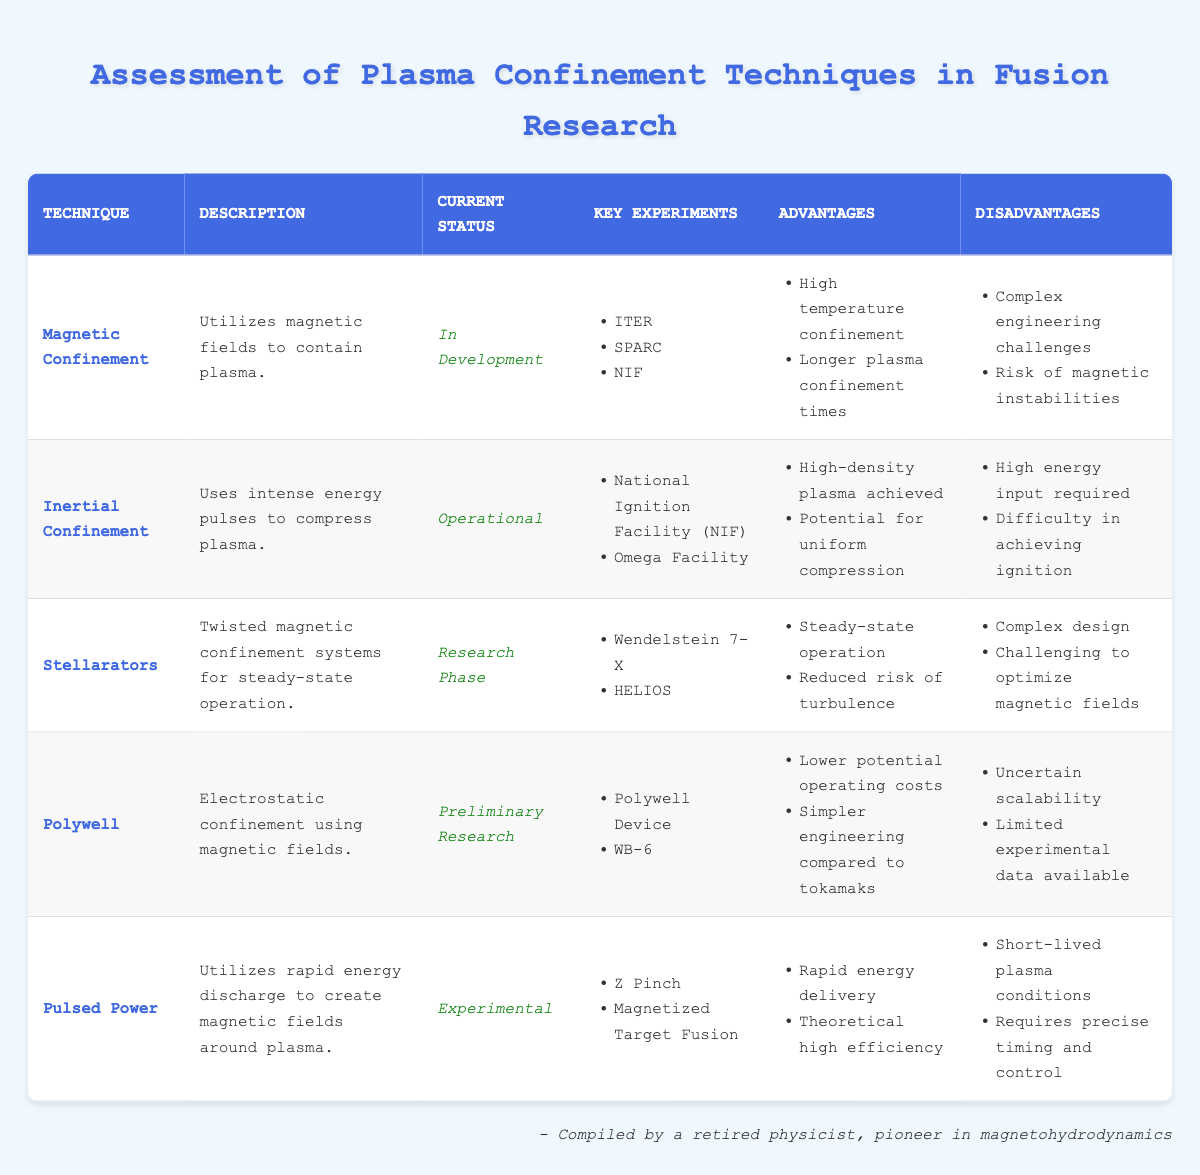What is the current status of Magnetic Confinement? The table explicitly states that the current status of Magnetic Confinement is "In Development".
Answer: In Development Which technique has the potential for uniform compression? The advantages listed for Inertial Confinement include "Potential for uniform compression".
Answer: Inertial Confinement How many key experiments are associated with Stellarators? The table indicates that there are two key experiments associated with Stellarators: Wendelstein 7-X and HELIOS.
Answer: 2 Is the Polywell technique currently operational? The current status of Polywell is noted as "Preliminary Research", which means it is not operational.
Answer: No Comparing the advantages, how many techniques have "high temperature confinement" listed? Only the Magnetic Confinement technique has "High temperature confinement" among its advantages.
Answer: 1 What are the disadvantages of Pulsed Power? The table lists two disadvantages for Pulsed Power: "Short-lived plasma conditions" and "Requires precise timing and control".
Answer: 2 Which plasma confinement technique is in the research phase and has reduced risk of turbulence? The technique is Stellarators, as highlighted in the table under its advantages.
Answer: Stellarators Which technique requires the highest energy input according to the disadvantages? The disadvantages of Inertial Confinement state that "High energy input required", indicating it requires the highest energy.
Answer: Inertial Confinement Out of the techniques listed, which has the lowest current status, and what is that status? The lowest current status indicated in the table is "Preliminary Research" for the Polywell technique.
Answer: Preliminary Research (Polywell) 